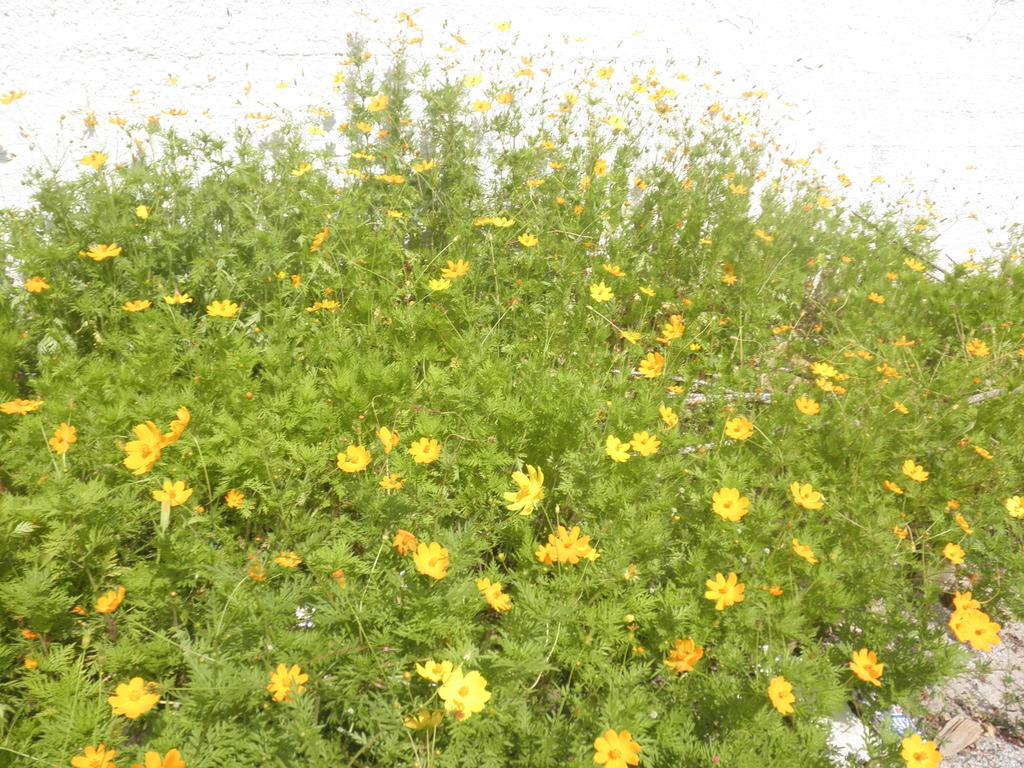What types of living organisms are in the image? There are plants and flowers in the image. What color is the background of the image? The background of the image is white. What type of soda is being poured into the pipe in the image? There is no soda or pipe present in the image; it features plants and flowers with a white background. 